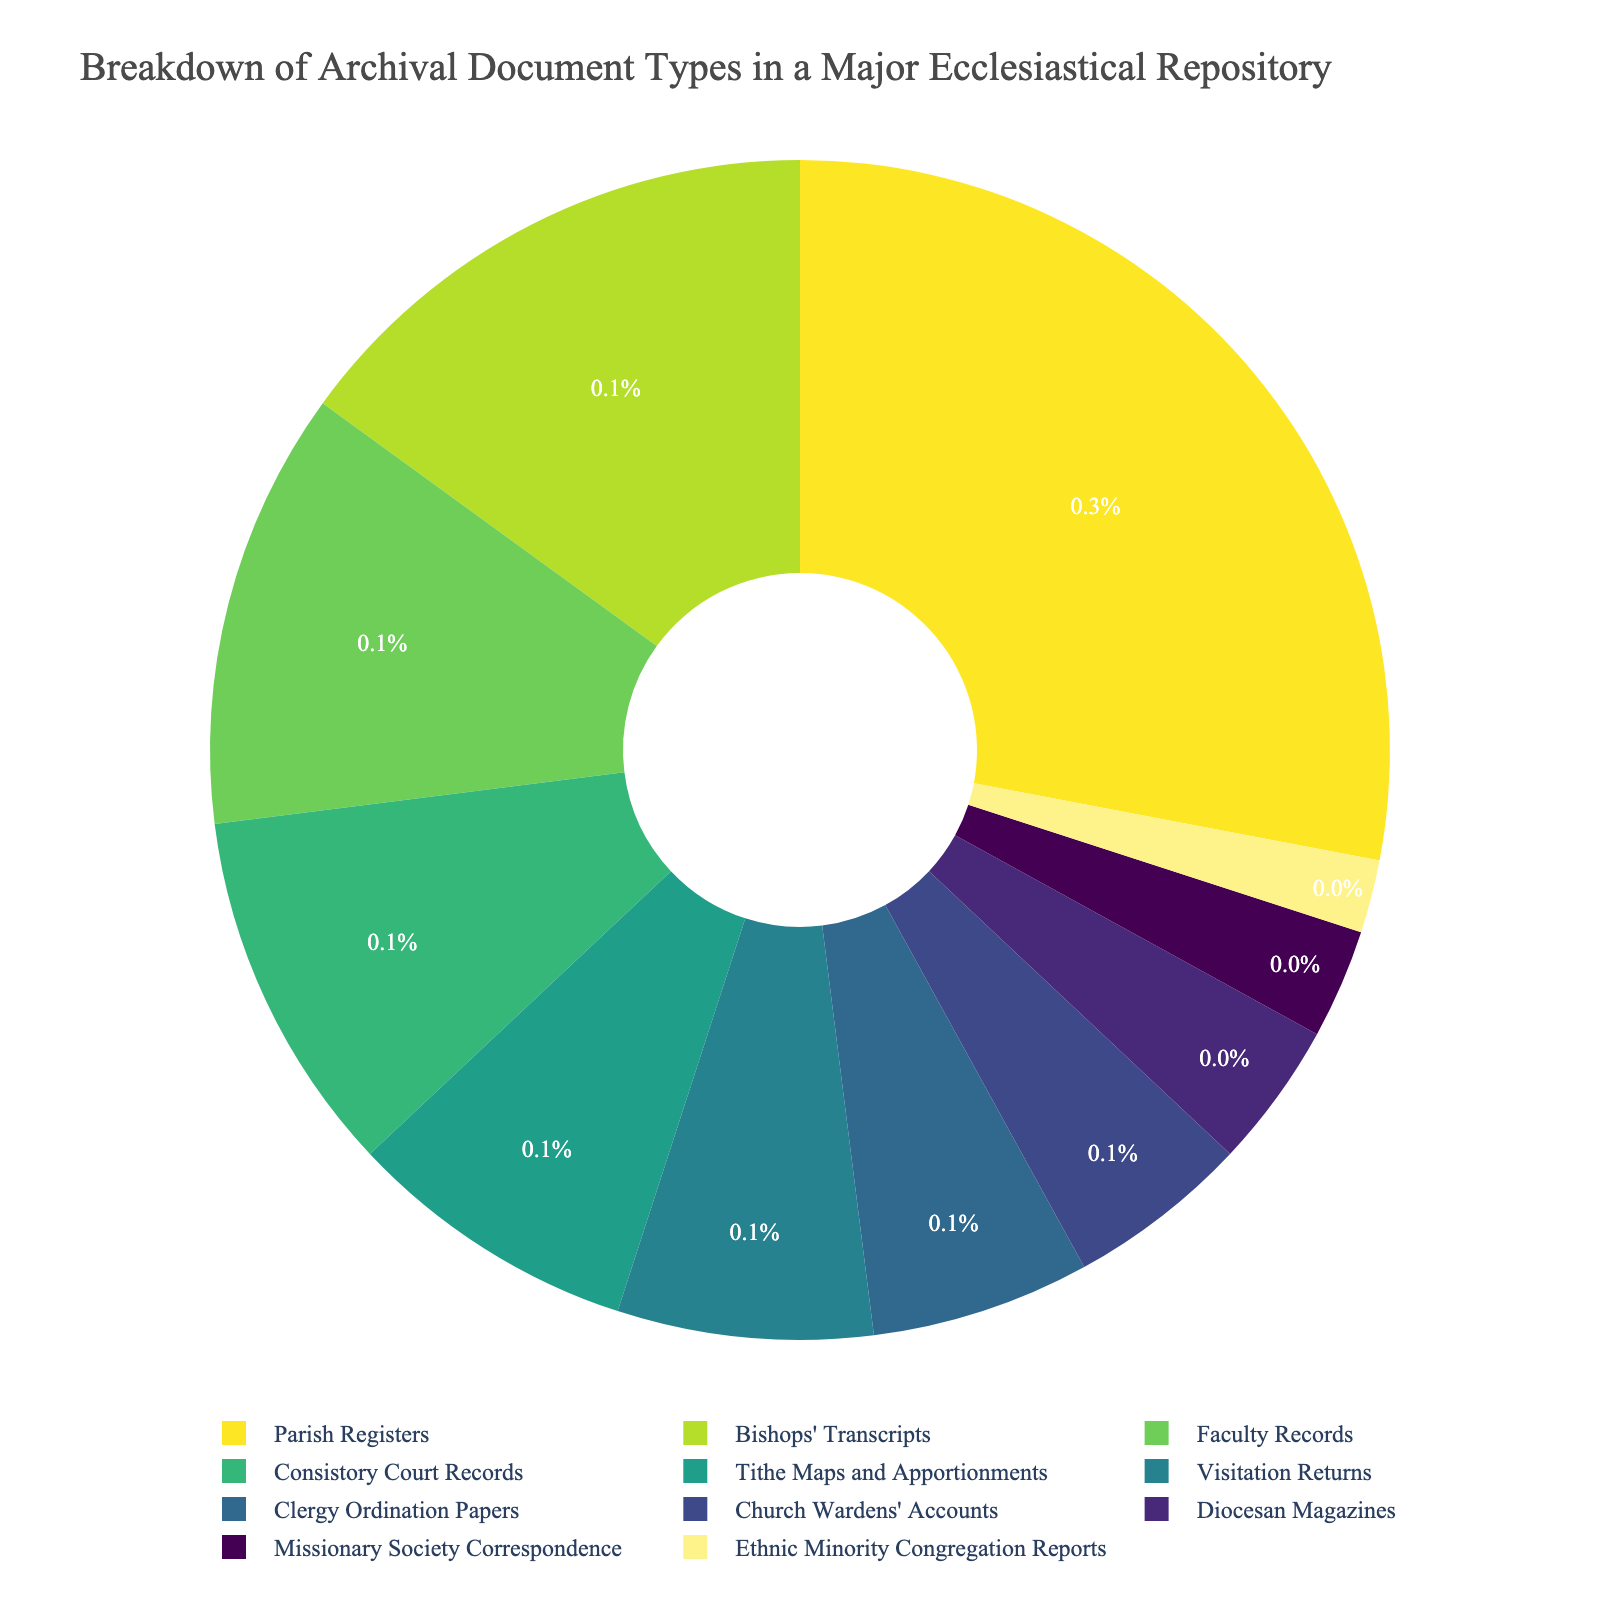Which document type has the largest percentage? By looking at the figure, identify the document type with the largest section size. It should be the biggest slice in the pie chart.
Answer: Parish Registers Which three document types together make up more than 50% of the repository? Add the percentages of the top three document types. Parish Registers (28%), Bishops' Transcripts (15%), and Faculty Records (12%). 28% + 15% + 12% = 55%, which is more than 50%.
Answer: Parish Registers, Bishops' Transcripts, and Faculty Records How does the percentage of Tithe Maps and Apportionments compare to that of Visitation Returns? Compare the sizes of the slices representing Tithe Maps and Apportionments (8%) and Visitation Returns (7%) in the pie chart. 8% is greater than 7%.
Answer: Tithe Maps and Apportionments is greater What is the sum of the percentages of the smallest four document types? Add the percentages of the smallest four document types: Missionary Society Correspondence (3%), Ethnic Minority Congregation Reports (2%), Diocesan Magazines (4%), and Church Wardens' Accounts (5%). 3% + 2% + 4% + 5% = 14%.
Answer: 14% What percentage of the repository is made up of Parish Registers and Bishops' Transcripts combined? Add the percentages of Parish Registers (28%) and Bishops' Transcripts (15%). 28% + 15% = 43%.
Answer: 43% Which document type has the least percentage? Identify the smallest section of the pie chart, which represents the document type with the least percentage.
Answer: Ethnic Minority Congregation Reports Are Visitation Returns and Clergy Ordination Papers cumulatively greater than Parish Registers? Add the percentages of Visitation Returns (7%) and Clergy Ordination Papers (6%) and compare the total (13%) with Parish Registers (28%). 13% < 28%.
Answer: No If Consistory Court Records and Faculty Records are combined, do they surpass Parish Registers? Add the percentages of Consistory Court Records (10%) and Faculty Records (12%) and compare the total (22%) with Parish Registers (28%). 22% < 28%.
Answer: No Which two document types together make up just over one-quarter of the repository? Identify the two document types whose combined percentage is just over 25%. Faculty Records (12%) and Consistory Court Records (10%) make 22%, but Parish Registers (28%) and Bishops' Transcripts (15%) together give 43%. Instead, Tithe Maps and Apportionments (8%) and Visitation Returns (7%) sum to 15%, which is less. Parish Registers alone is 28%, thus Parish Registers and one smaller type.
Answer: Parish Registers alone at 28% 